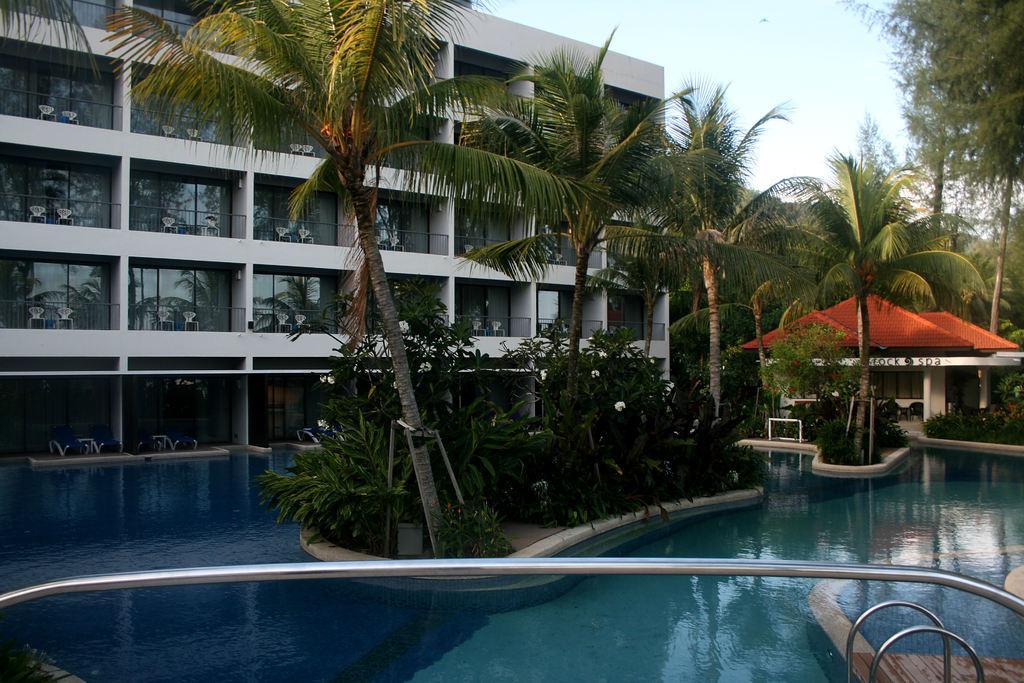In one or two sentences, can you explain what this image depicts? In this picture we can see there are trees, swimming pool, buildings. Behind the building, there is the sky. At the bottom of the image, there are iron rods. 